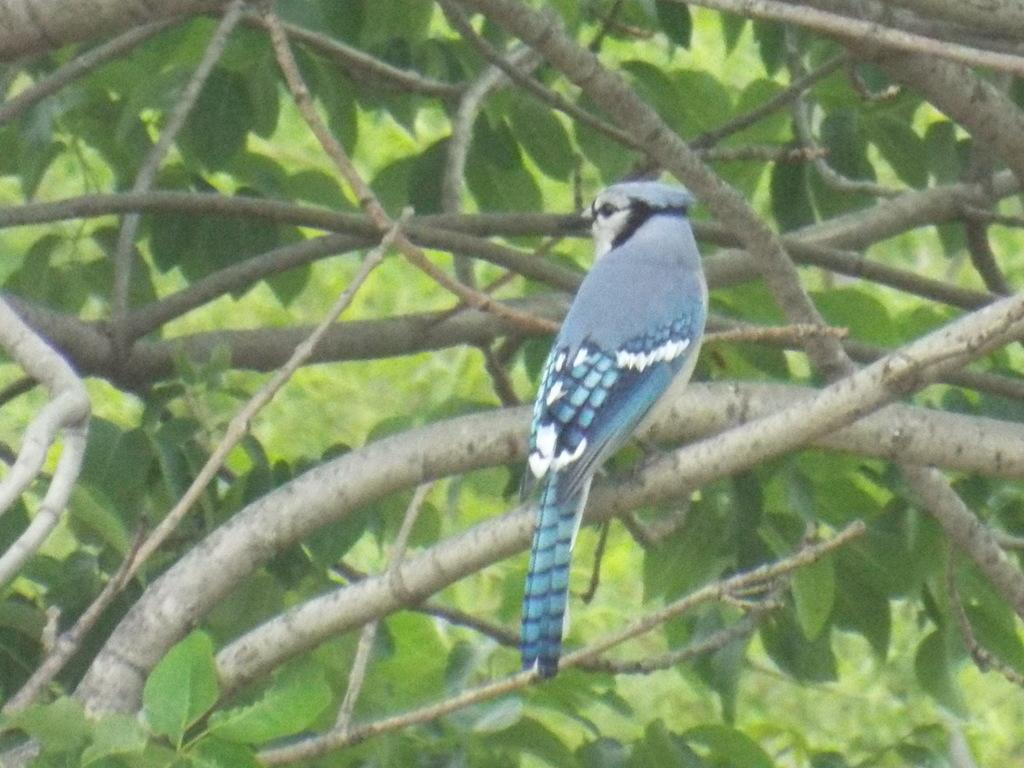What type of animal can be seen in the image? There is a bird in the image. Where is the bird located? The bird is on a branch. What type of vegetation is visible in the image? There are green leaves visible in the image. What colors can be seen on the bird? The bird has blue and white colors. What type of pin is holding the flag in the image? There is no pin or flag present in the image; it features a bird on a branch with green leaves. How does the bird's memory affect its behavior in the image? The image does not provide information about the bird's memory or behavior. 